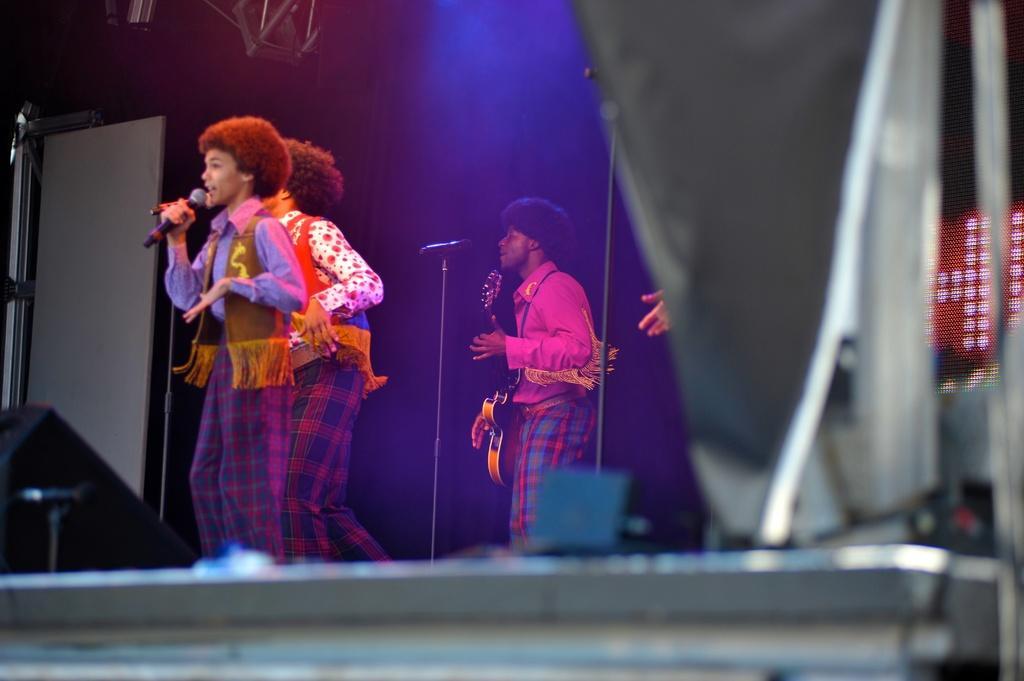Please provide a concise description of this image. In this image we can see two children are standing on the stage holding the mikes. On the right side we can see a person holding a guitar standing in front of a mic and a mic stand. 